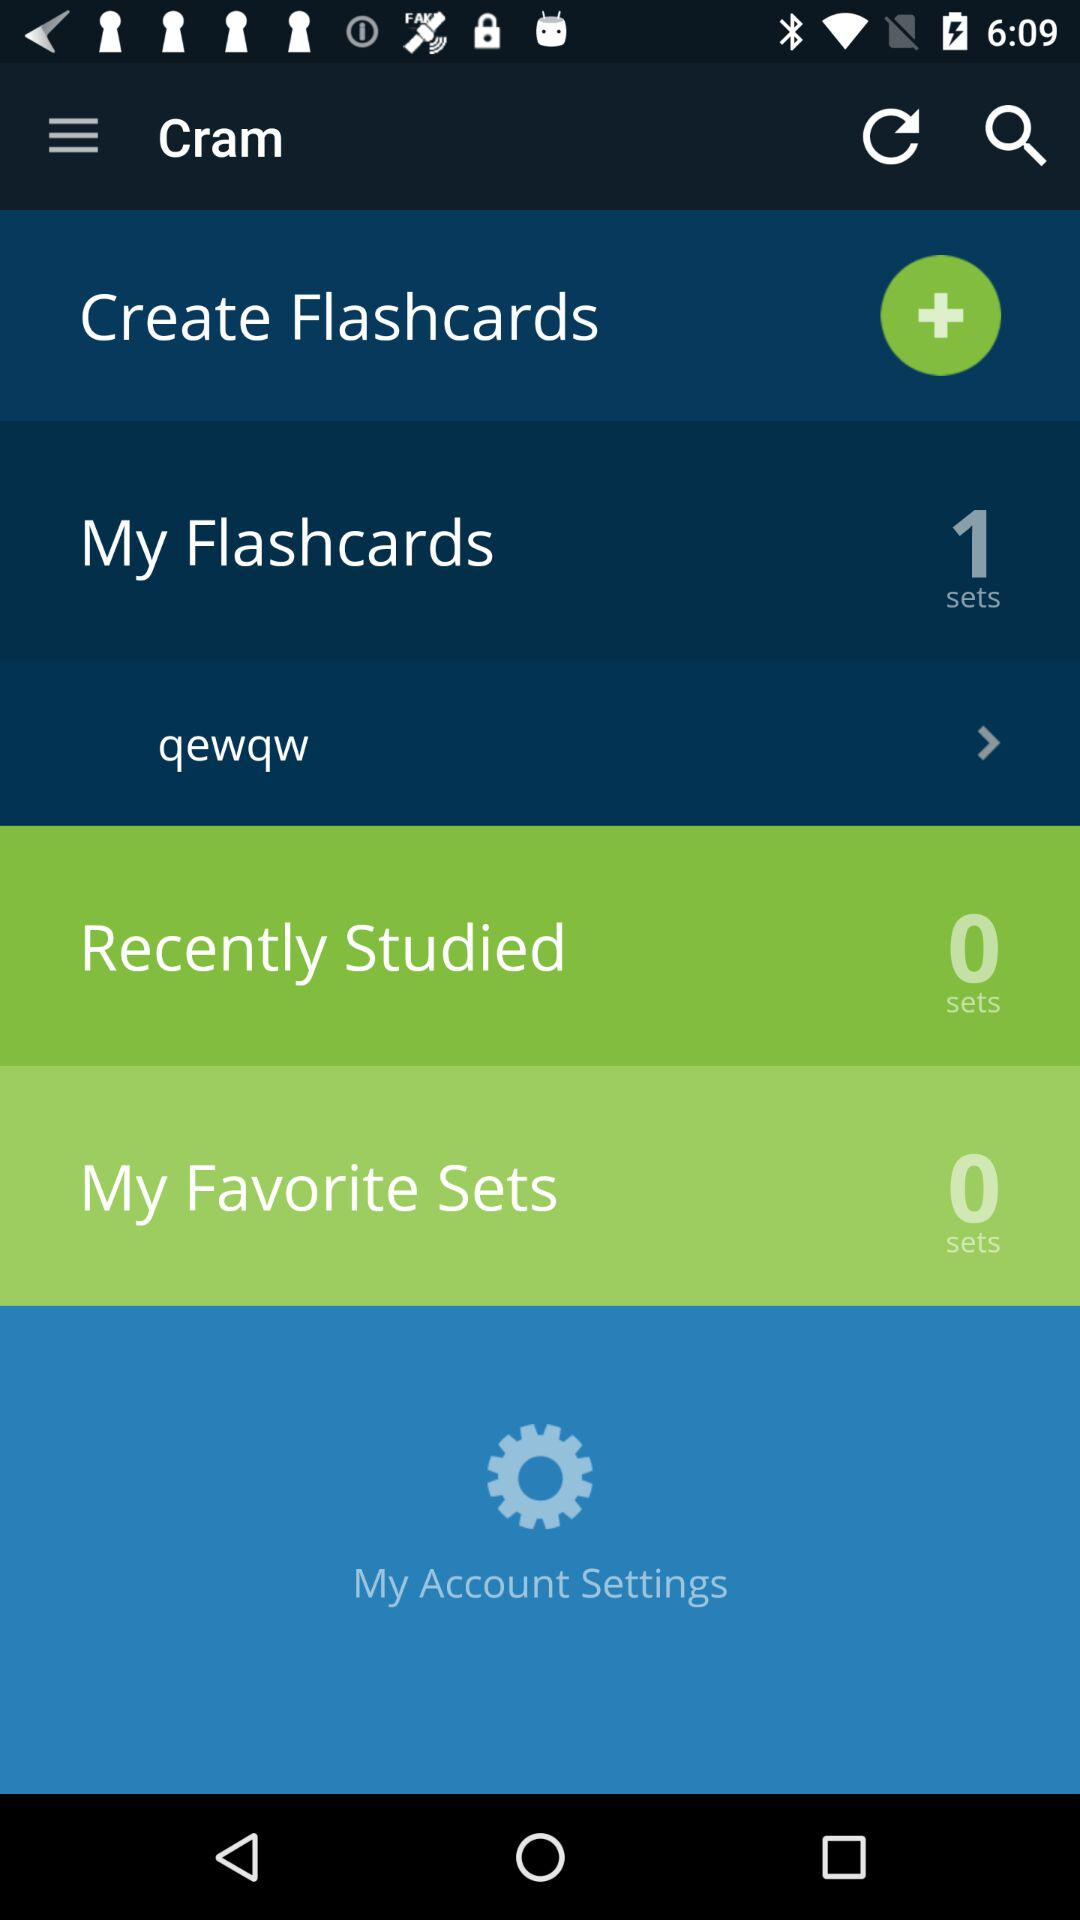What is the count of sets in "Recently Studied"? The count of sets is 0. 